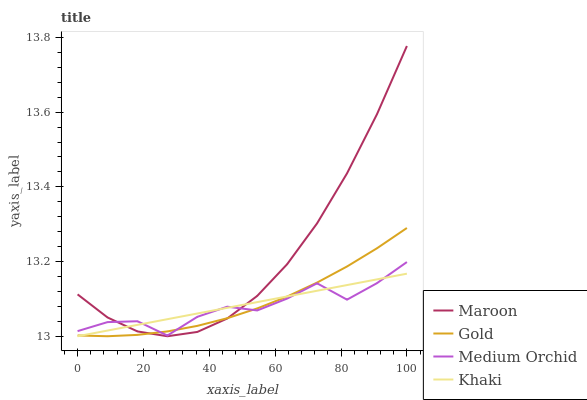Does Medium Orchid have the minimum area under the curve?
Answer yes or no. Yes. Does Maroon have the maximum area under the curve?
Answer yes or no. Yes. Does Khaki have the minimum area under the curve?
Answer yes or no. No. Does Khaki have the maximum area under the curve?
Answer yes or no. No. Is Khaki the smoothest?
Answer yes or no. Yes. Is Medium Orchid the roughest?
Answer yes or no. Yes. Is Gold the smoothest?
Answer yes or no. No. Is Gold the roughest?
Answer yes or no. No. Does Khaki have the lowest value?
Answer yes or no. Yes. Does Gold have the lowest value?
Answer yes or no. No. Does Maroon have the highest value?
Answer yes or no. Yes. Does Gold have the highest value?
Answer yes or no. No. Does Medium Orchid intersect Khaki?
Answer yes or no. Yes. Is Medium Orchid less than Khaki?
Answer yes or no. No. Is Medium Orchid greater than Khaki?
Answer yes or no. No. 